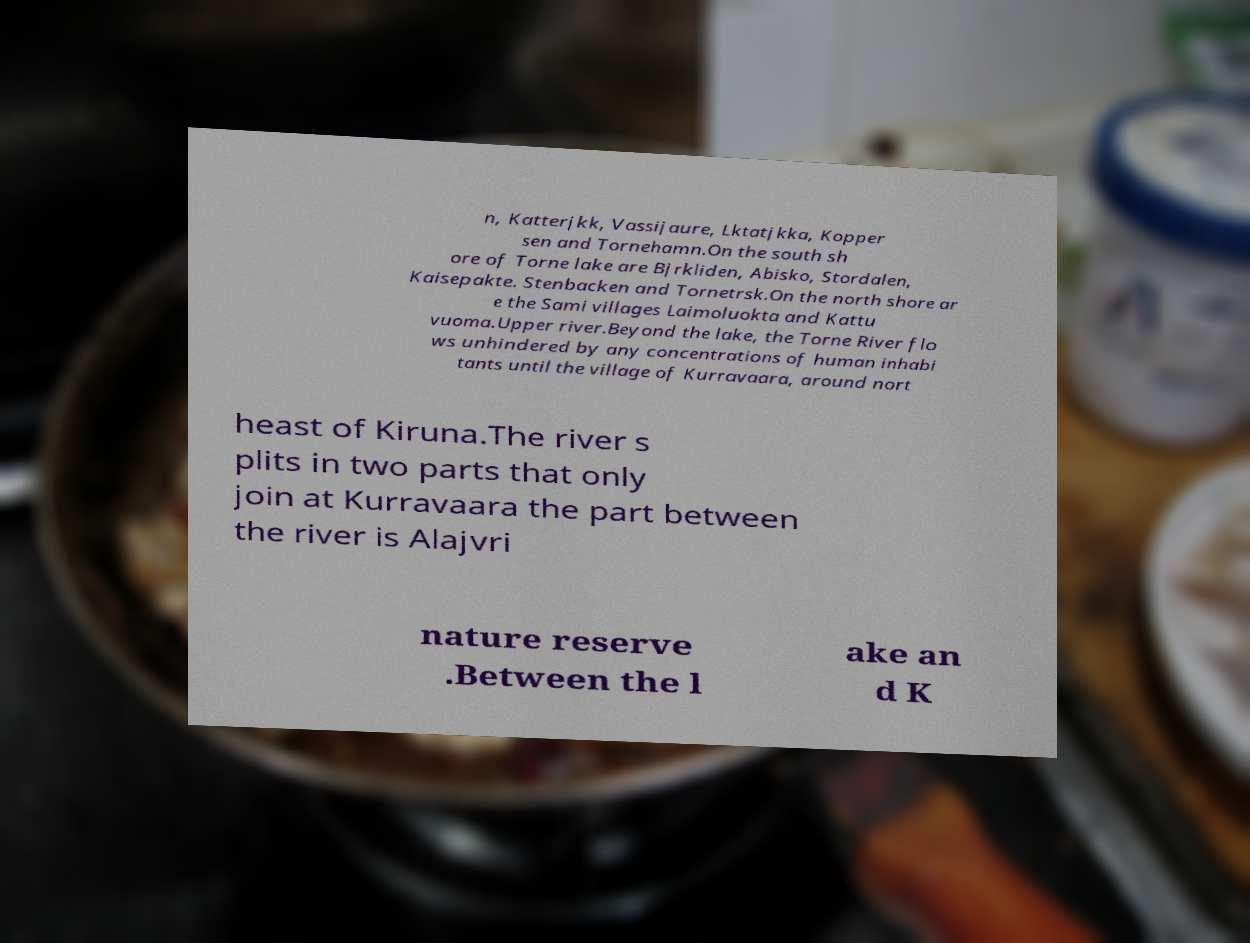Please read and relay the text visible in this image. What does it say? n, Katterjkk, Vassijaure, Lktatjkka, Kopper sen and Tornehamn.On the south sh ore of Torne lake are Bjrkliden, Abisko, Stordalen, Kaisepakte. Stenbacken and Tornetrsk.On the north shore ar e the Sami villages Laimoluokta and Kattu vuoma.Upper river.Beyond the lake, the Torne River flo ws unhindered by any concentrations of human inhabi tants until the village of Kurravaara, around nort heast of Kiruna.The river s plits in two parts that only join at Kurravaara the part between the river is Alajvri nature reserve .Between the l ake an d K 